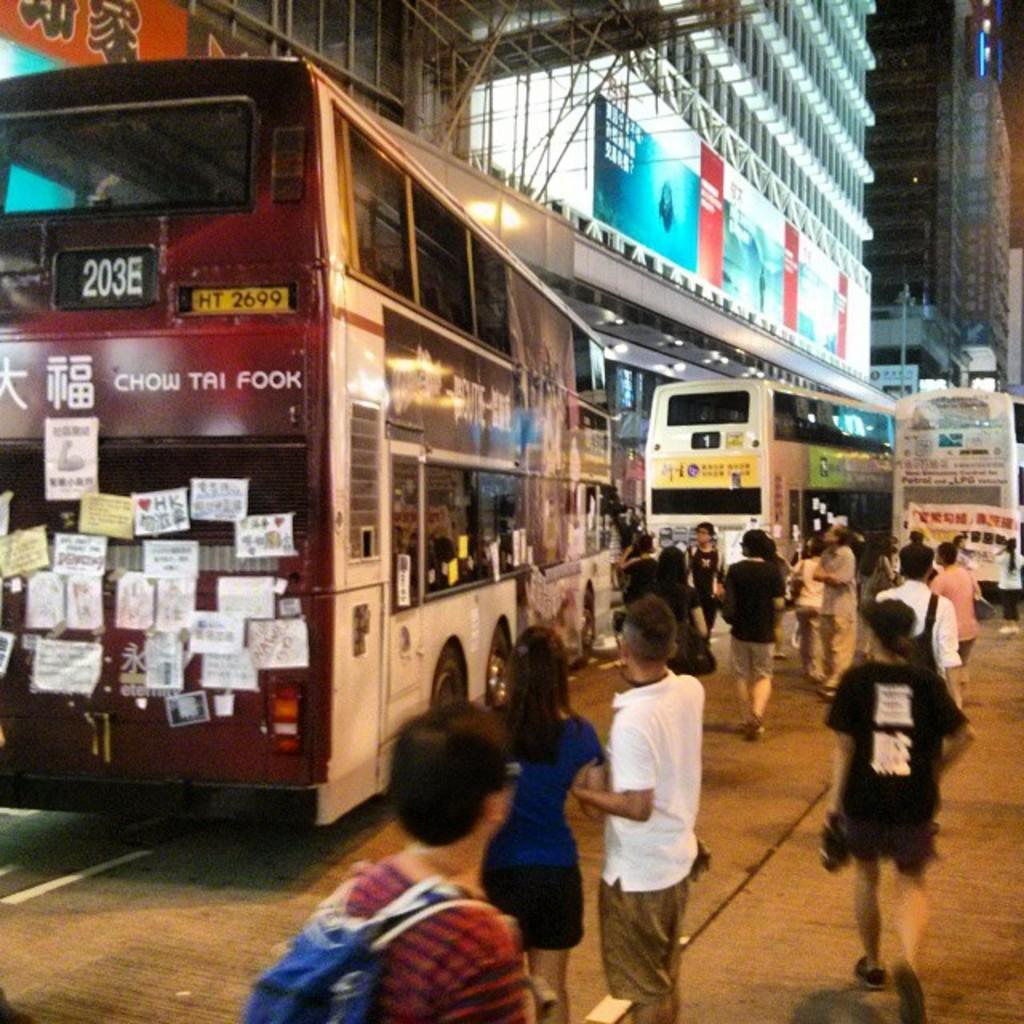Provide a one-sentence caption for the provided image. The 203E bus is pulling away from the corner onto the street. 